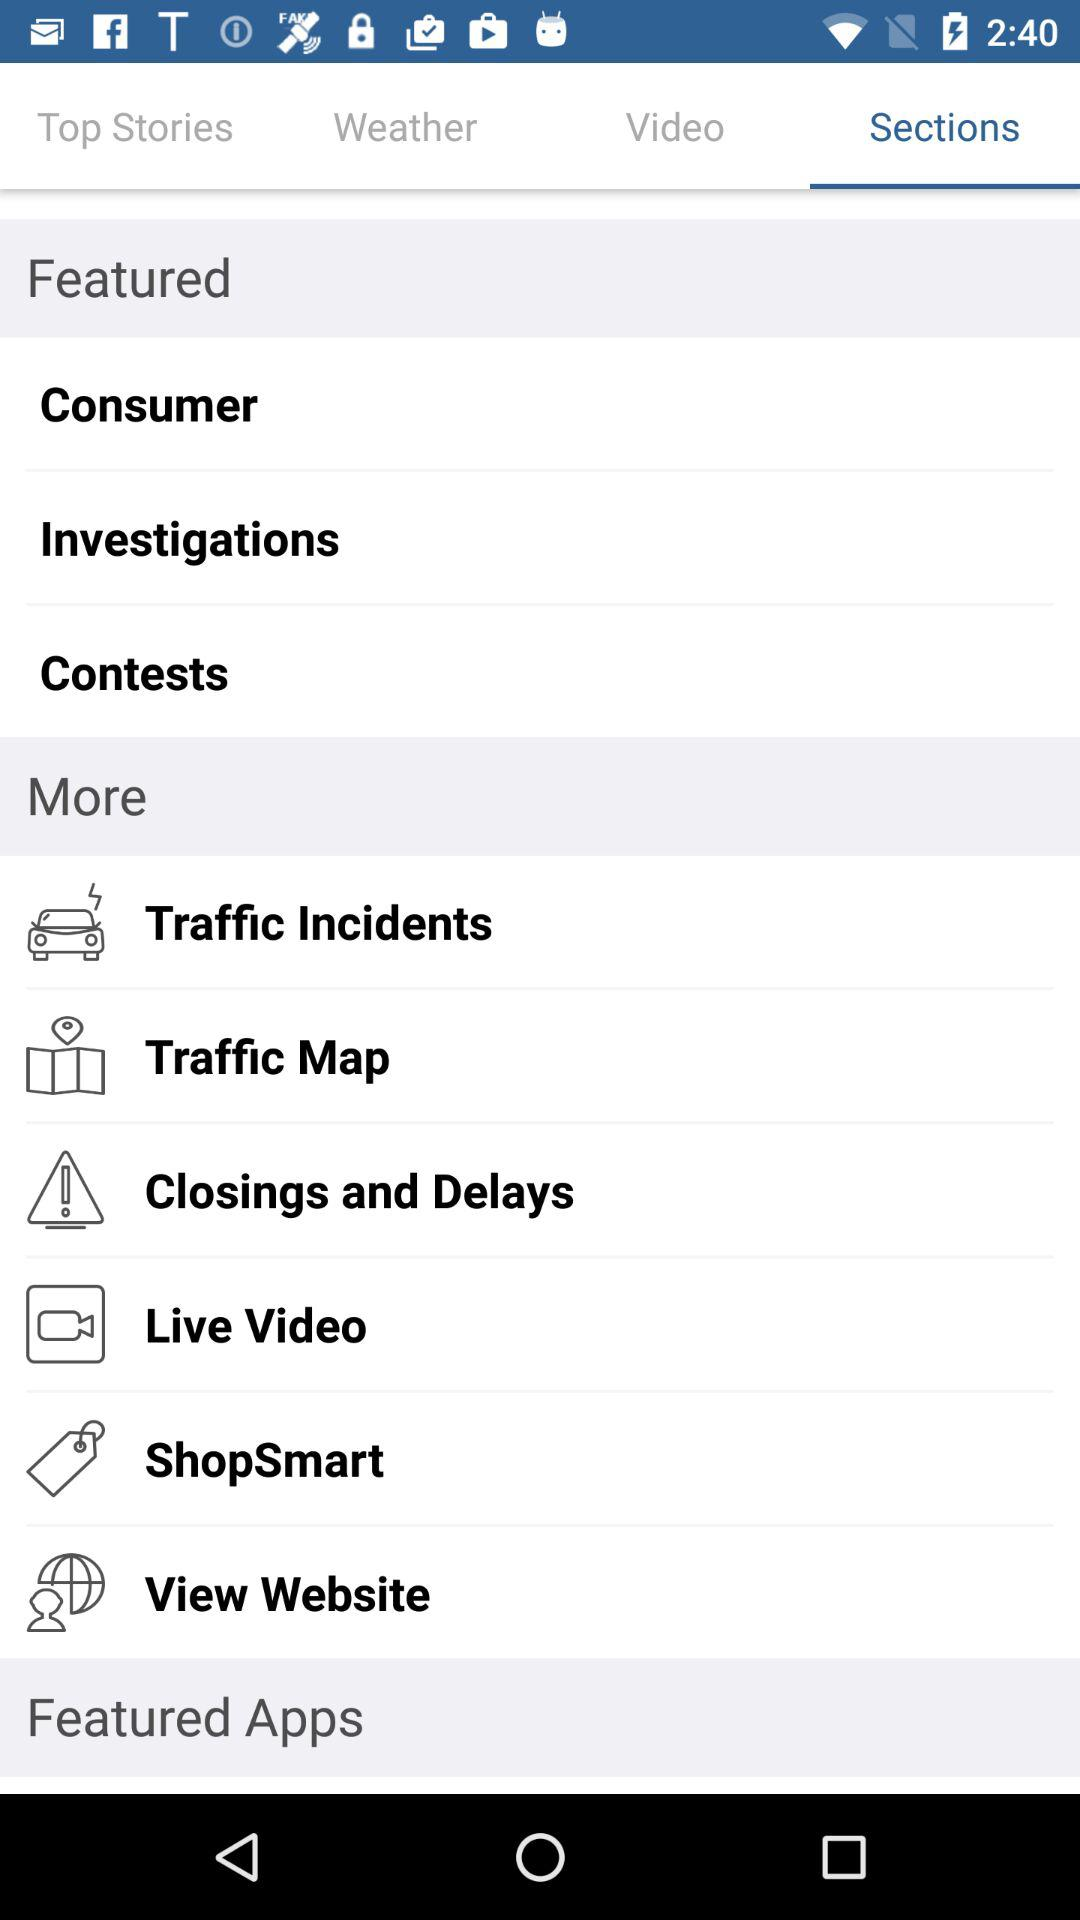Which tab is selected? The selected tab is "Sections". 